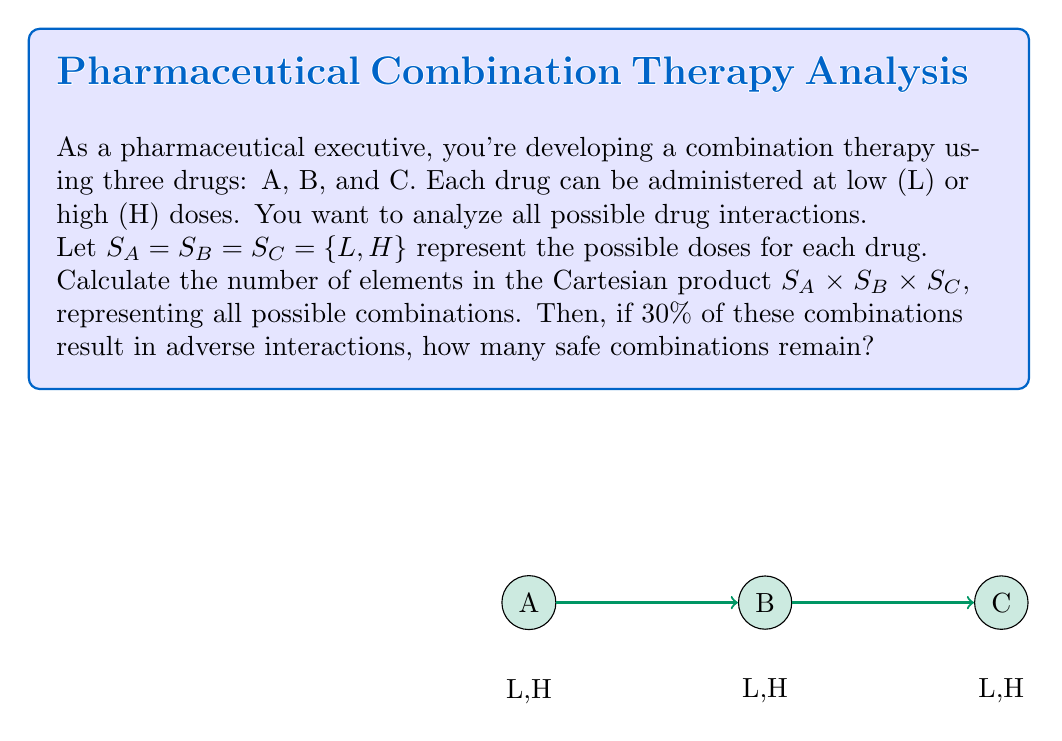Can you answer this question? Let's approach this step-by-step:

1) First, we need to calculate the Cartesian product $S_A \times S_B \times S_C$:
   
   $S_A \times S_B \times S_C = \{(x,y,z) | x \in S_A, y \in S_B, z \in S_C\}$

2) To find the number of elements in this Cartesian product, we multiply the number of elements in each set:
   
   $|S_A \times S_B \times S_C| = |S_A| \cdot |S_B| \cdot |S_C|$

3) Each set (S_A, S_B, S_C) has 2 elements (L and H), so:
   
   $|S_A \times S_B \times S_C| = 2 \cdot 2 \cdot 2 = 8$

4) This means there are 8 possible combinations in total.

5) If 30% of these combinations result in adverse interactions:
   
   Number of adverse combinations $= 30\% \text{ of } 8 = 0.3 \cdot 8 = 2.4$

   Since we can't have a fractional number of combinations, we round this to 2.

6) Therefore, the number of safe combinations is:
   
   Safe combinations $= \text{Total combinations} - \text{Adverse combinations}$
                     $= 8 - 2 = 6$

Thus, 6 safe combinations remain.
Answer: 6 